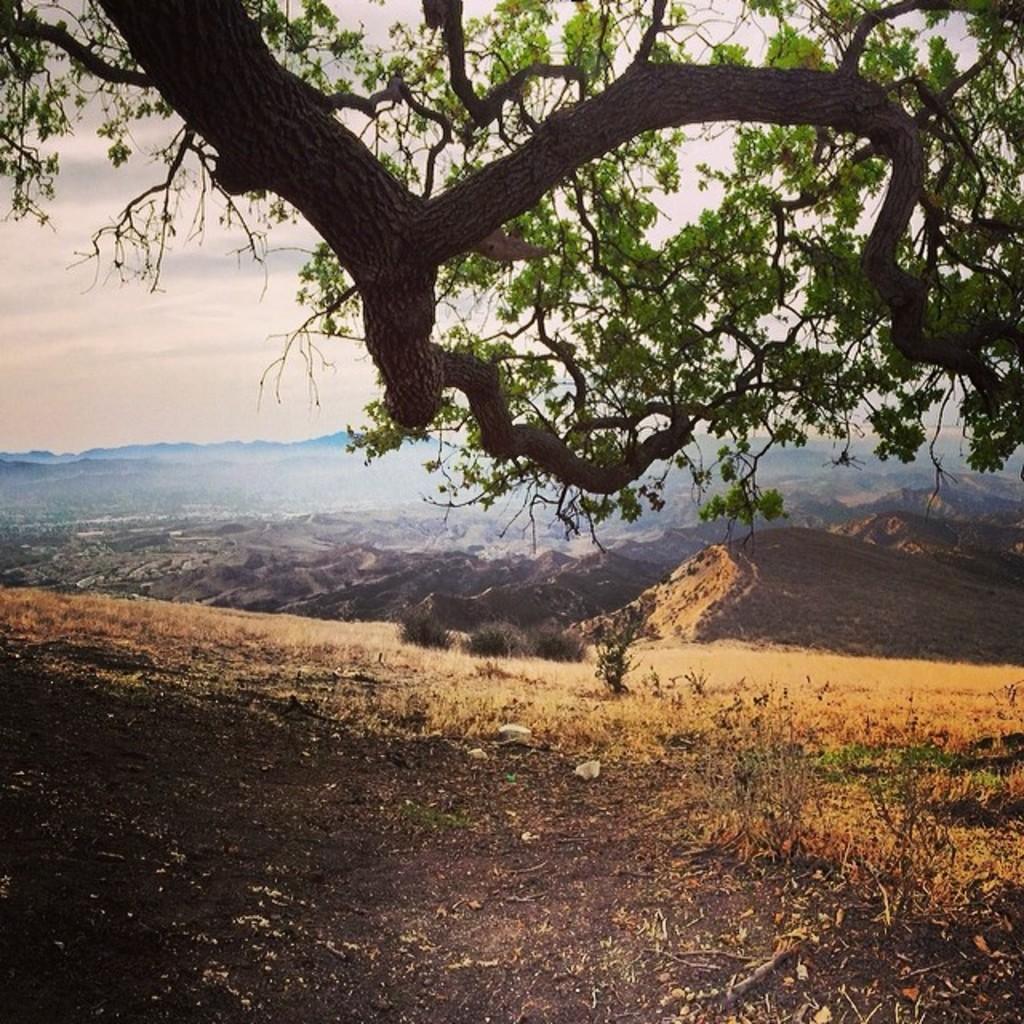Describe this image in one or two sentences. In this picture we can see a tree, in the background we can find few hills. 